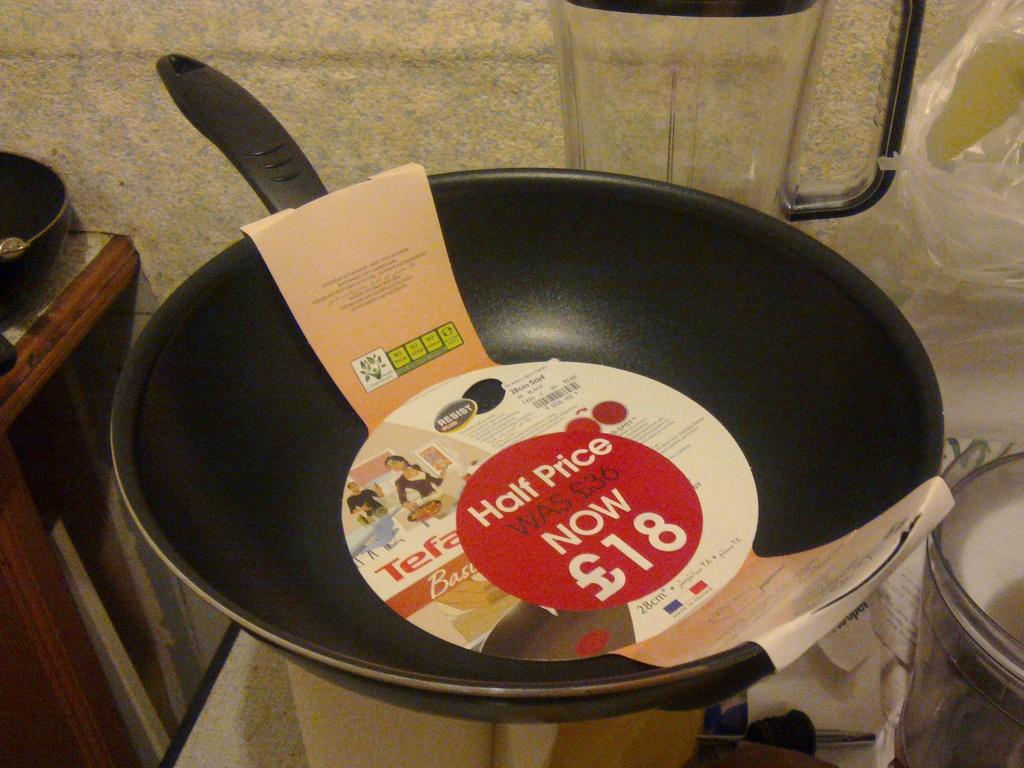What did the pan originally cost?
Ensure brevity in your answer.  36. 